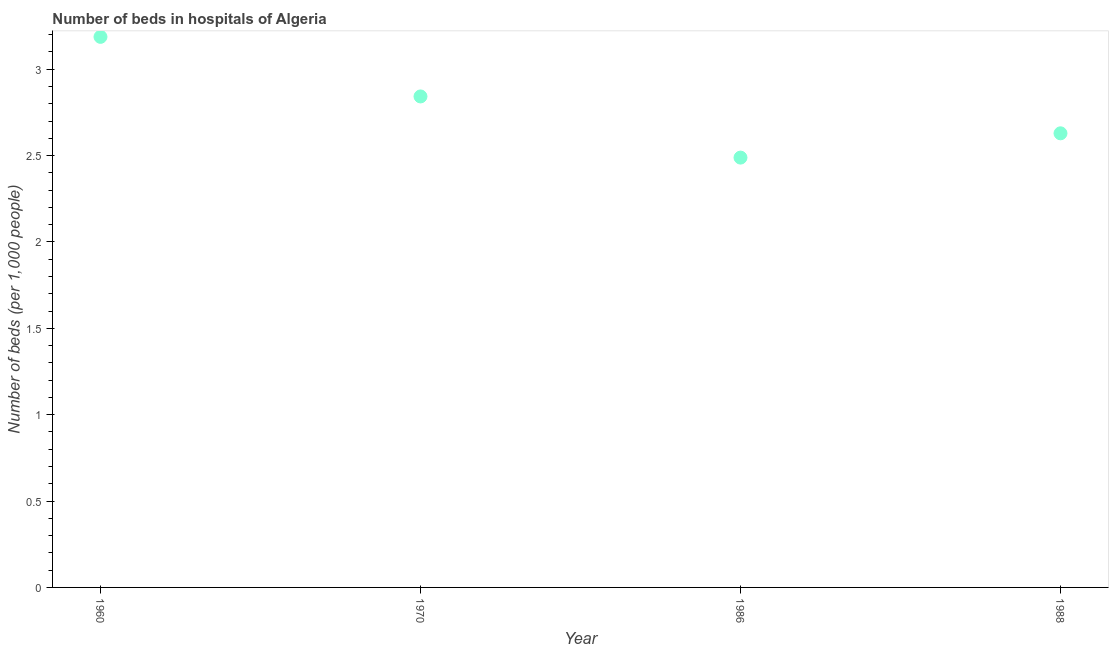What is the number of hospital beds in 1970?
Your answer should be very brief. 2.84. Across all years, what is the maximum number of hospital beds?
Make the answer very short. 3.19. Across all years, what is the minimum number of hospital beds?
Offer a terse response. 2.49. In which year was the number of hospital beds maximum?
Give a very brief answer. 1960. What is the sum of the number of hospital beds?
Make the answer very short. 11.15. What is the difference between the number of hospital beds in 1970 and 1986?
Your answer should be very brief. 0.35. What is the average number of hospital beds per year?
Your answer should be very brief. 2.79. What is the median number of hospital beds?
Your answer should be compact. 2.74. In how many years, is the number of hospital beds greater than 0.5 %?
Keep it short and to the point. 4. Do a majority of the years between 1970 and 1988 (inclusive) have number of hospital beds greater than 0.9 %?
Make the answer very short. Yes. What is the ratio of the number of hospital beds in 1970 to that in 1988?
Offer a terse response. 1.08. Is the number of hospital beds in 1986 less than that in 1988?
Ensure brevity in your answer.  Yes. What is the difference between the highest and the second highest number of hospital beds?
Offer a terse response. 0.34. What is the difference between the highest and the lowest number of hospital beds?
Provide a succinct answer. 0.7. Does the number of hospital beds monotonically increase over the years?
Your response must be concise. No. How many years are there in the graph?
Offer a very short reply. 4. What is the difference between two consecutive major ticks on the Y-axis?
Offer a terse response. 0.5. Does the graph contain any zero values?
Ensure brevity in your answer.  No. Does the graph contain grids?
Offer a terse response. No. What is the title of the graph?
Keep it short and to the point. Number of beds in hospitals of Algeria. What is the label or title of the X-axis?
Make the answer very short. Year. What is the label or title of the Y-axis?
Ensure brevity in your answer.  Number of beds (per 1,0 people). What is the Number of beds (per 1,000 people) in 1960?
Keep it short and to the point. 3.19. What is the Number of beds (per 1,000 people) in 1970?
Give a very brief answer. 2.84. What is the Number of beds (per 1,000 people) in 1986?
Provide a short and direct response. 2.49. What is the Number of beds (per 1,000 people) in 1988?
Offer a terse response. 2.63. What is the difference between the Number of beds (per 1,000 people) in 1960 and 1970?
Provide a short and direct response. 0.34. What is the difference between the Number of beds (per 1,000 people) in 1960 and 1986?
Your answer should be very brief. 0.7. What is the difference between the Number of beds (per 1,000 people) in 1960 and 1988?
Provide a short and direct response. 0.56. What is the difference between the Number of beds (per 1,000 people) in 1970 and 1986?
Provide a succinct answer. 0.35. What is the difference between the Number of beds (per 1,000 people) in 1970 and 1988?
Provide a succinct answer. 0.21. What is the difference between the Number of beds (per 1,000 people) in 1986 and 1988?
Provide a succinct answer. -0.14. What is the ratio of the Number of beds (per 1,000 people) in 1960 to that in 1970?
Provide a short and direct response. 1.12. What is the ratio of the Number of beds (per 1,000 people) in 1960 to that in 1986?
Ensure brevity in your answer.  1.28. What is the ratio of the Number of beds (per 1,000 people) in 1960 to that in 1988?
Ensure brevity in your answer.  1.21. What is the ratio of the Number of beds (per 1,000 people) in 1970 to that in 1986?
Offer a terse response. 1.14. What is the ratio of the Number of beds (per 1,000 people) in 1970 to that in 1988?
Provide a short and direct response. 1.08. What is the ratio of the Number of beds (per 1,000 people) in 1986 to that in 1988?
Make the answer very short. 0.95. 